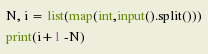Convert code to text. <code><loc_0><loc_0><loc_500><loc_500><_Python_>N, i = list(map(int,input().split()))
print(i+1 -N)
</code> 